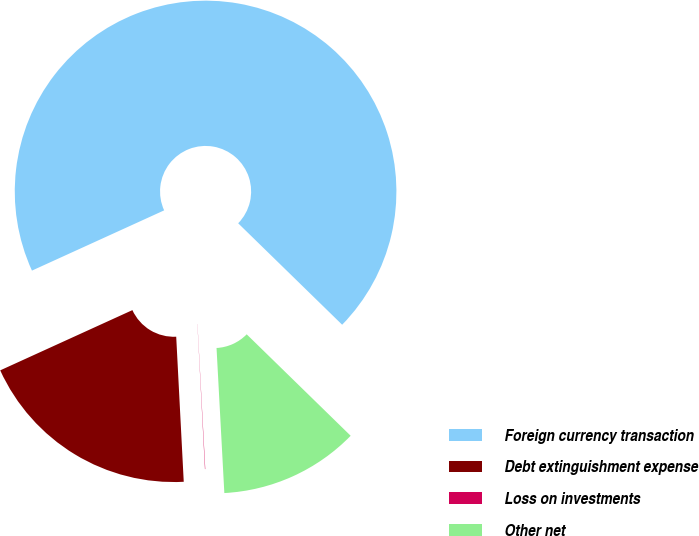<chart> <loc_0><loc_0><loc_500><loc_500><pie_chart><fcel>Foreign currency transaction<fcel>Debt extinguishment expense<fcel>Loss on investments<fcel>Other net<nl><fcel>69.11%<fcel>19.02%<fcel>0.03%<fcel>11.84%<nl></chart> 